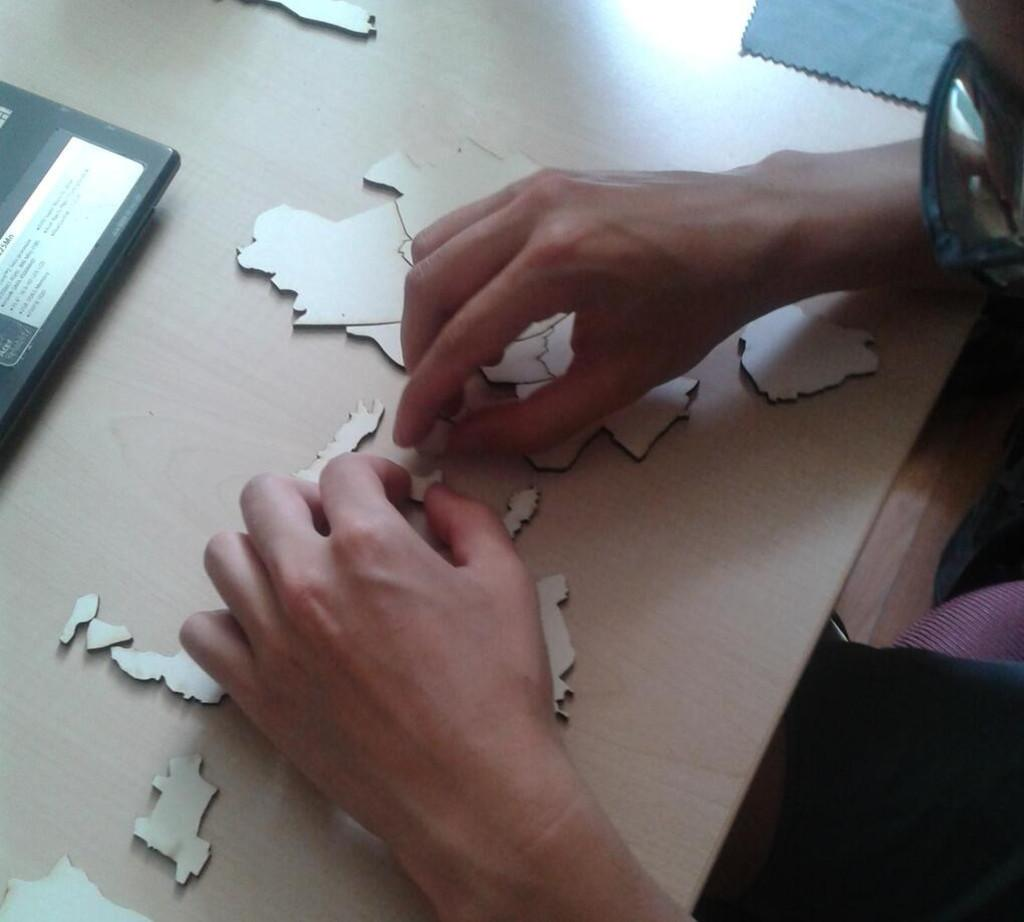What is the person in the image doing? The person in the image is solving a puzzle. What part of the person can be seen in the image? The person's hands are visible in the image. What type of material is the cloth in the image made of? The facts do not specify the material of the cloth. What is the object on the wooden platform in the image? The facts do not specify the object on the wooden platform. How does the person feel about receiving mail in the image? There is no mail or mailbox present in the image, so it is not possible to determine how the person feels about receiving mail. 